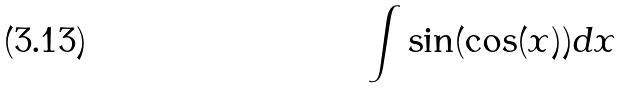Convert formula to latex. <formula><loc_0><loc_0><loc_500><loc_500>\int \sin ( \cos ( x ) ) d x</formula> 